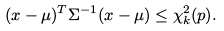Convert formula to latex. <formula><loc_0><loc_0><loc_500><loc_500>( { x } - { \mu } ) ^ { T } { \Sigma } ^ { - 1 } ( { x } - { \mu } ) \leq \chi _ { k } ^ { 2 } ( p ) .</formula> 